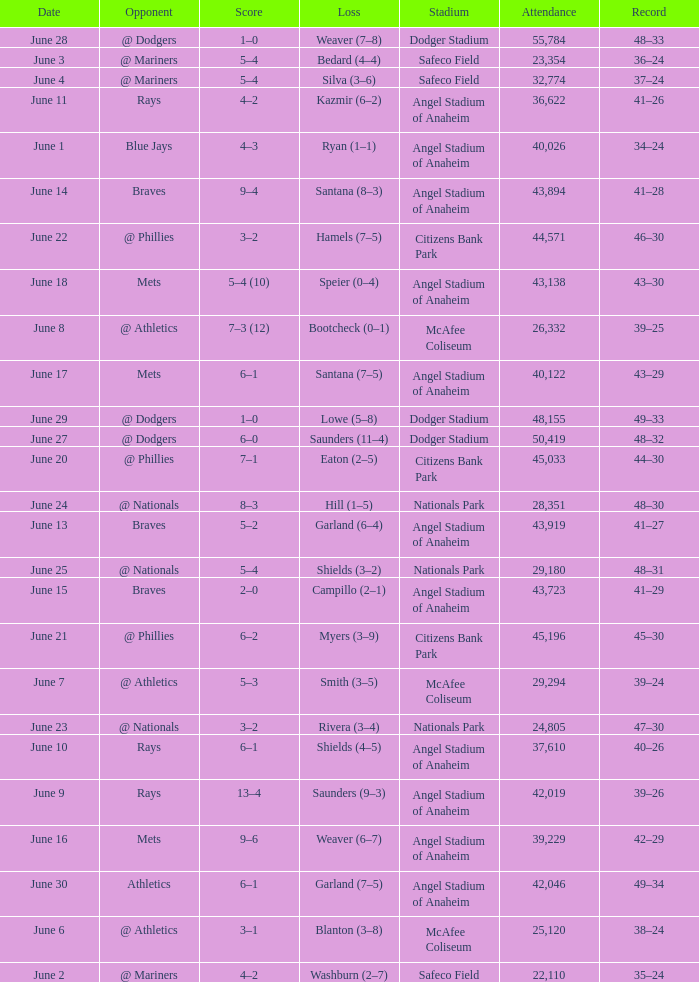What was the score of the game against the Braves with a record of 41–27? 5–2. 